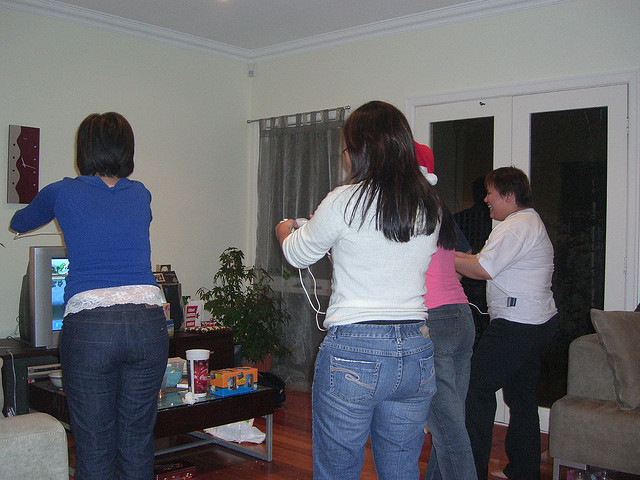How many people are there? There are four individuals in the room, engaged in what appears to be a lively and entertaining activity that involves a video game. 